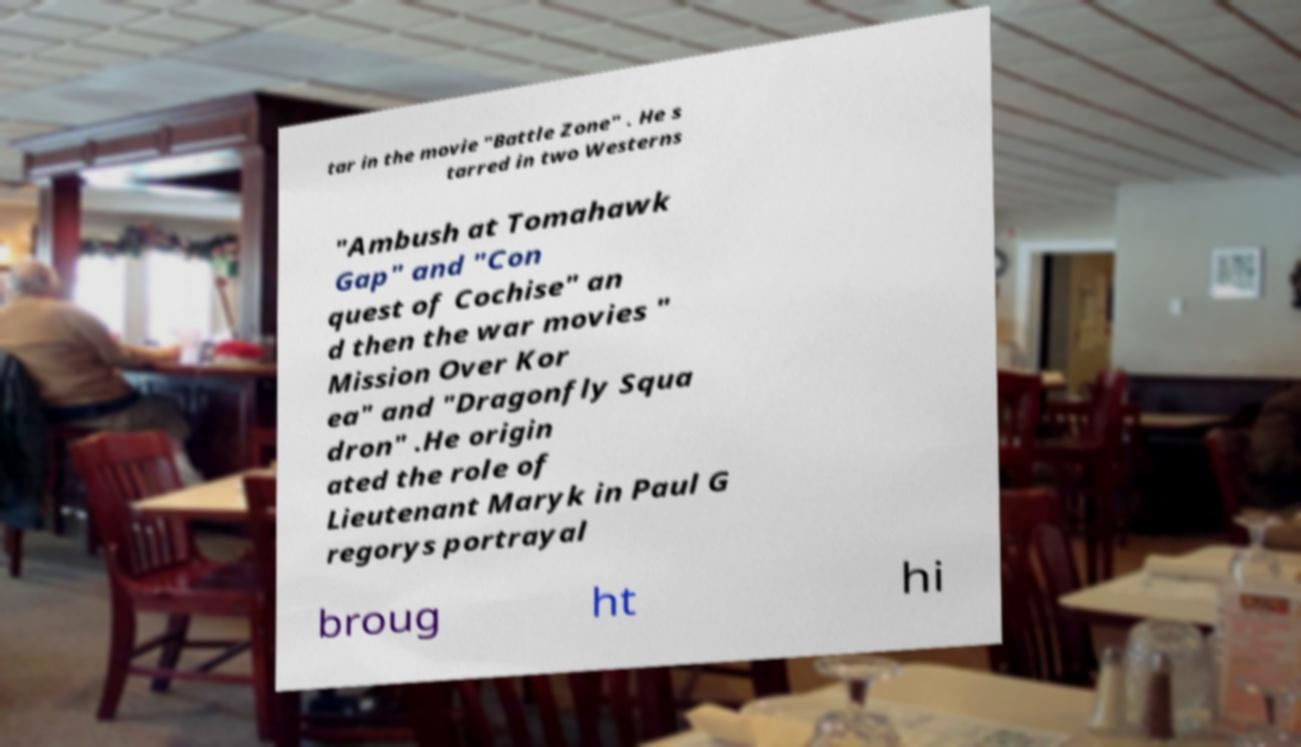Could you assist in decoding the text presented in this image and type it out clearly? tar in the movie "Battle Zone" . He s tarred in two Westerns "Ambush at Tomahawk Gap" and "Con quest of Cochise" an d then the war movies " Mission Over Kor ea" and "Dragonfly Squa dron" .He origin ated the role of Lieutenant Maryk in Paul G regorys portrayal broug ht hi 